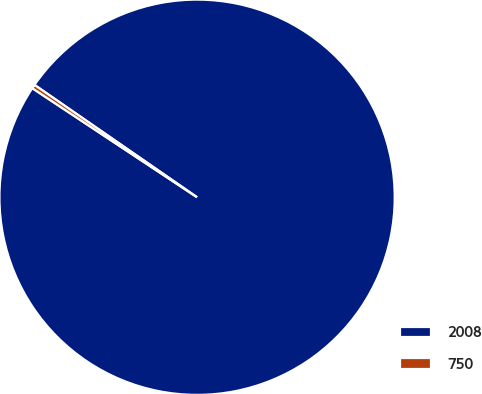<chart> <loc_0><loc_0><loc_500><loc_500><pie_chart><fcel>2008<fcel>750<nl><fcel>99.68%<fcel>0.32%<nl></chart> 